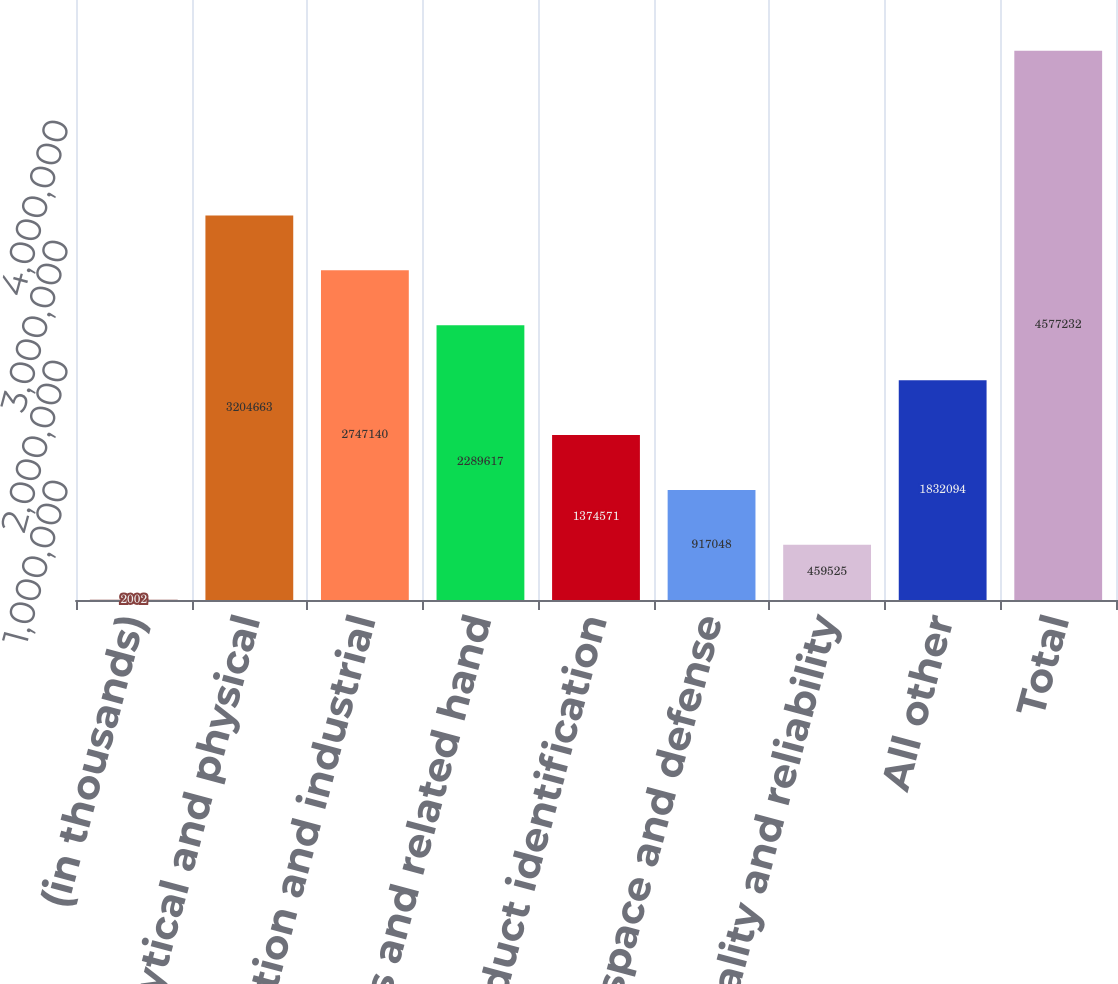Convert chart. <chart><loc_0><loc_0><loc_500><loc_500><bar_chart><fcel>(in thousands)<fcel>Analytical and physical<fcel>Motion and industrial<fcel>Mechanics and related hand<fcel>Product identification<fcel>Aerospace and defense<fcel>Power quality and reliability<fcel>All other<fcel>Total<nl><fcel>2002<fcel>3.20466e+06<fcel>2.74714e+06<fcel>2.28962e+06<fcel>1.37457e+06<fcel>917048<fcel>459525<fcel>1.83209e+06<fcel>4.57723e+06<nl></chart> 